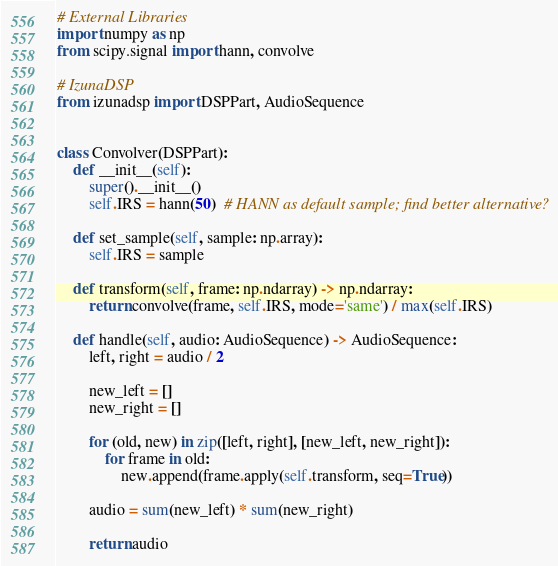<code> <loc_0><loc_0><loc_500><loc_500><_Python_># External Libraries
import numpy as np
from scipy.signal import hann, convolve

# IzunaDSP
from izunadsp import DSPPart, AudioSequence


class Convolver(DSPPart):
    def __init__(self):
        super().__init__()
        self.IRS = hann(50)  # HANN as default sample; find better alternative?

    def set_sample(self, sample: np.array):
        self.IRS = sample

    def transform(self, frame: np.ndarray) -> np.ndarray:
        return convolve(frame, self.IRS, mode='same') / max(self.IRS)

    def handle(self, audio: AudioSequence) -> AudioSequence:
        left, right = audio / 2

        new_left = []
        new_right = []

        for (old, new) in zip([left, right], [new_left, new_right]):
            for frame in old:
                new.append(frame.apply(self.transform, seq=True))

        audio = sum(new_left) * sum(new_right)

        return audio
</code> 